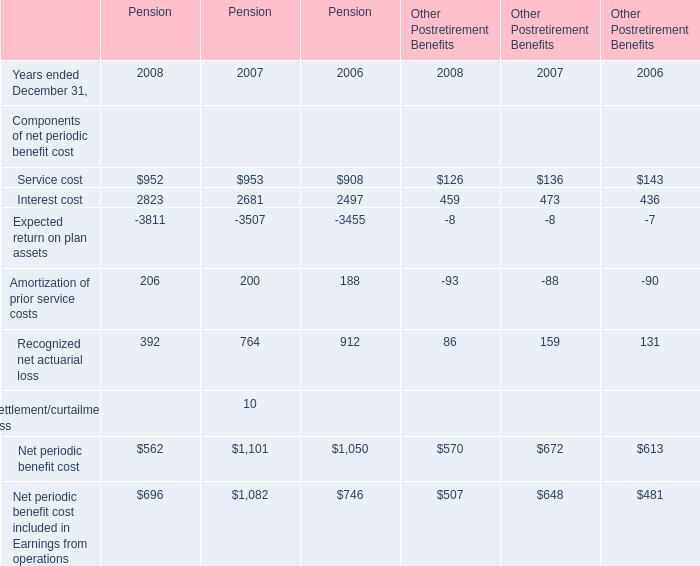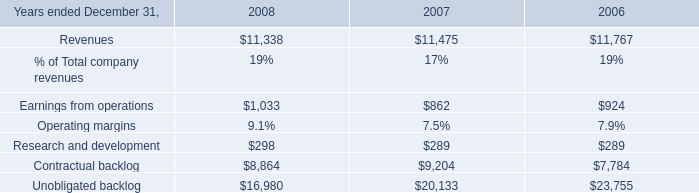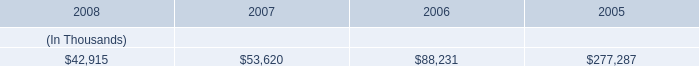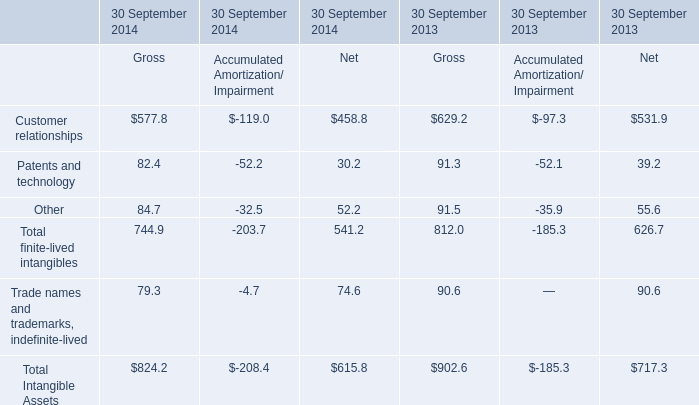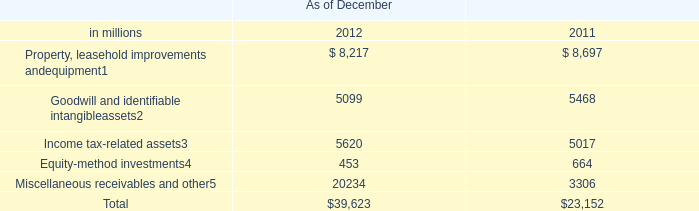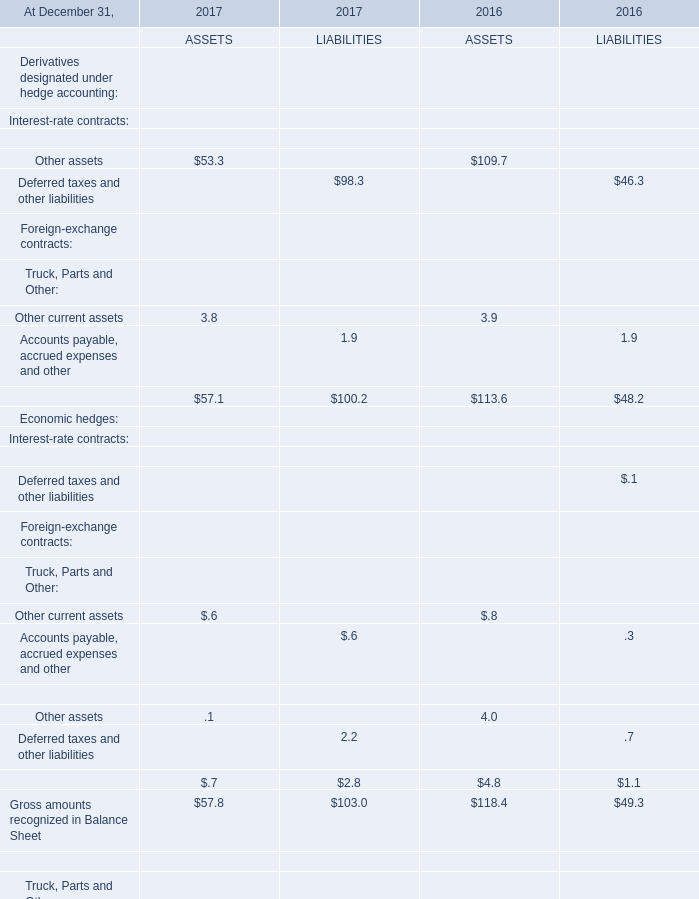what's the total amount of Net periodic benefit cost of Pension 2007, and Unobligated backlog of 2006 ? 
Computations: (1101.0 + 23755.0)
Answer: 24856.0. 